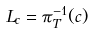Convert formula to latex. <formula><loc_0><loc_0><loc_500><loc_500>L _ { c } = \pi ^ { - 1 } _ { T } ( c )</formula> 